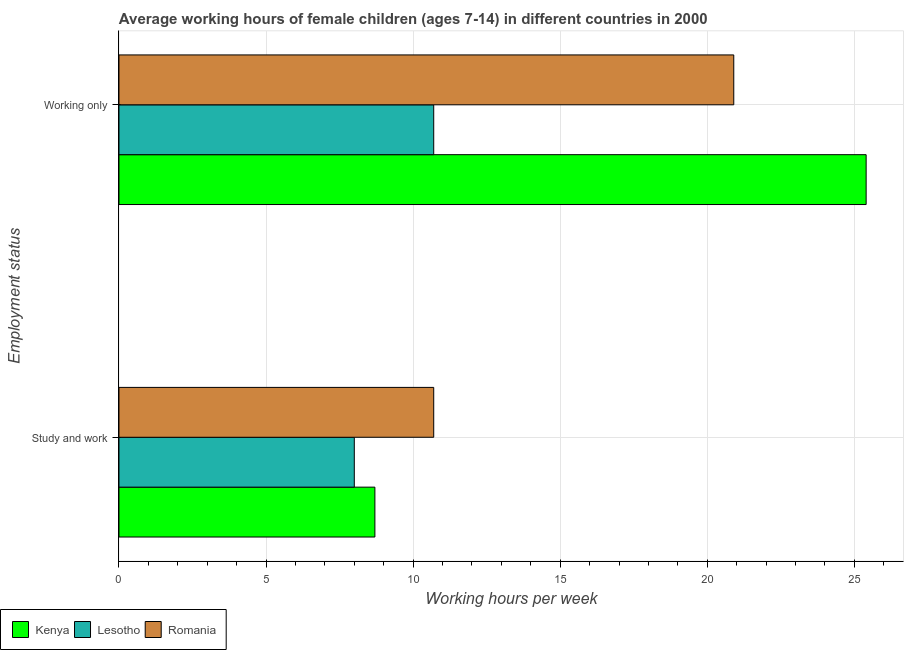How many different coloured bars are there?
Offer a terse response. 3. How many bars are there on the 1st tick from the top?
Ensure brevity in your answer.  3. What is the label of the 2nd group of bars from the top?
Offer a very short reply. Study and work. Across all countries, what is the maximum average working hour of children involved in only work?
Ensure brevity in your answer.  25.4. Across all countries, what is the minimum average working hour of children involved in only work?
Your response must be concise. 10.7. In which country was the average working hour of children involved in only work maximum?
Your response must be concise. Kenya. In which country was the average working hour of children involved in study and work minimum?
Offer a very short reply. Lesotho. What is the total average working hour of children involved in study and work in the graph?
Provide a short and direct response. 27.4. What is the difference between the average working hour of children involved in only work in Lesotho and that in Romania?
Your response must be concise. -10.2. What is the difference between the average working hour of children involved in study and work in Lesotho and the average working hour of children involved in only work in Romania?
Your response must be concise. -12.9. What is the average average working hour of children involved in study and work per country?
Provide a succinct answer. 9.13. What is the difference between the average working hour of children involved in only work and average working hour of children involved in study and work in Kenya?
Make the answer very short. 16.7. In how many countries, is the average working hour of children involved in study and work greater than 11 hours?
Give a very brief answer. 0. What is the ratio of the average working hour of children involved in only work in Romania to that in Lesotho?
Offer a very short reply. 1.95. Is the average working hour of children involved in study and work in Romania less than that in Lesotho?
Give a very brief answer. No. In how many countries, is the average working hour of children involved in only work greater than the average average working hour of children involved in only work taken over all countries?
Your answer should be very brief. 2. What does the 1st bar from the top in Working only represents?
Ensure brevity in your answer.  Romania. What does the 1st bar from the bottom in Study and work represents?
Provide a succinct answer. Kenya. How many countries are there in the graph?
Your answer should be very brief. 3. What is the difference between two consecutive major ticks on the X-axis?
Offer a very short reply. 5. Are the values on the major ticks of X-axis written in scientific E-notation?
Your answer should be compact. No. Does the graph contain any zero values?
Offer a terse response. No. Where does the legend appear in the graph?
Offer a very short reply. Bottom left. How many legend labels are there?
Your answer should be compact. 3. What is the title of the graph?
Give a very brief answer. Average working hours of female children (ages 7-14) in different countries in 2000. What is the label or title of the X-axis?
Provide a short and direct response. Working hours per week. What is the label or title of the Y-axis?
Provide a succinct answer. Employment status. What is the Working hours per week of Lesotho in Study and work?
Provide a short and direct response. 8. What is the Working hours per week in Kenya in Working only?
Provide a succinct answer. 25.4. What is the Working hours per week of Romania in Working only?
Your response must be concise. 20.9. Across all Employment status, what is the maximum Working hours per week in Kenya?
Offer a very short reply. 25.4. Across all Employment status, what is the maximum Working hours per week in Lesotho?
Offer a terse response. 10.7. Across all Employment status, what is the maximum Working hours per week in Romania?
Your answer should be compact. 20.9. Across all Employment status, what is the minimum Working hours per week in Romania?
Make the answer very short. 10.7. What is the total Working hours per week of Kenya in the graph?
Your response must be concise. 34.1. What is the total Working hours per week in Lesotho in the graph?
Provide a short and direct response. 18.7. What is the total Working hours per week in Romania in the graph?
Ensure brevity in your answer.  31.6. What is the difference between the Working hours per week of Kenya in Study and work and that in Working only?
Offer a very short reply. -16.7. What is the difference between the Working hours per week of Lesotho in Study and work and that in Working only?
Your answer should be compact. -2.7. What is the difference between the Working hours per week of Kenya in Study and work and the Working hours per week of Lesotho in Working only?
Your answer should be compact. -2. What is the average Working hours per week of Kenya per Employment status?
Offer a terse response. 17.05. What is the average Working hours per week of Lesotho per Employment status?
Offer a very short reply. 9.35. What is the difference between the Working hours per week of Kenya and Working hours per week of Romania in Study and work?
Provide a short and direct response. -2. What is the difference between the Working hours per week of Lesotho and Working hours per week of Romania in Study and work?
Keep it short and to the point. -2.7. What is the difference between the Working hours per week in Kenya and Working hours per week in Lesotho in Working only?
Give a very brief answer. 14.7. What is the difference between the Working hours per week of Lesotho and Working hours per week of Romania in Working only?
Offer a terse response. -10.2. What is the ratio of the Working hours per week in Kenya in Study and work to that in Working only?
Offer a very short reply. 0.34. What is the ratio of the Working hours per week in Lesotho in Study and work to that in Working only?
Make the answer very short. 0.75. What is the ratio of the Working hours per week of Romania in Study and work to that in Working only?
Provide a short and direct response. 0.51. What is the difference between the highest and the second highest Working hours per week in Lesotho?
Provide a succinct answer. 2.7. What is the difference between the highest and the second highest Working hours per week of Romania?
Your response must be concise. 10.2. What is the difference between the highest and the lowest Working hours per week of Kenya?
Your response must be concise. 16.7. What is the difference between the highest and the lowest Working hours per week in Lesotho?
Your answer should be compact. 2.7. What is the difference between the highest and the lowest Working hours per week in Romania?
Give a very brief answer. 10.2. 